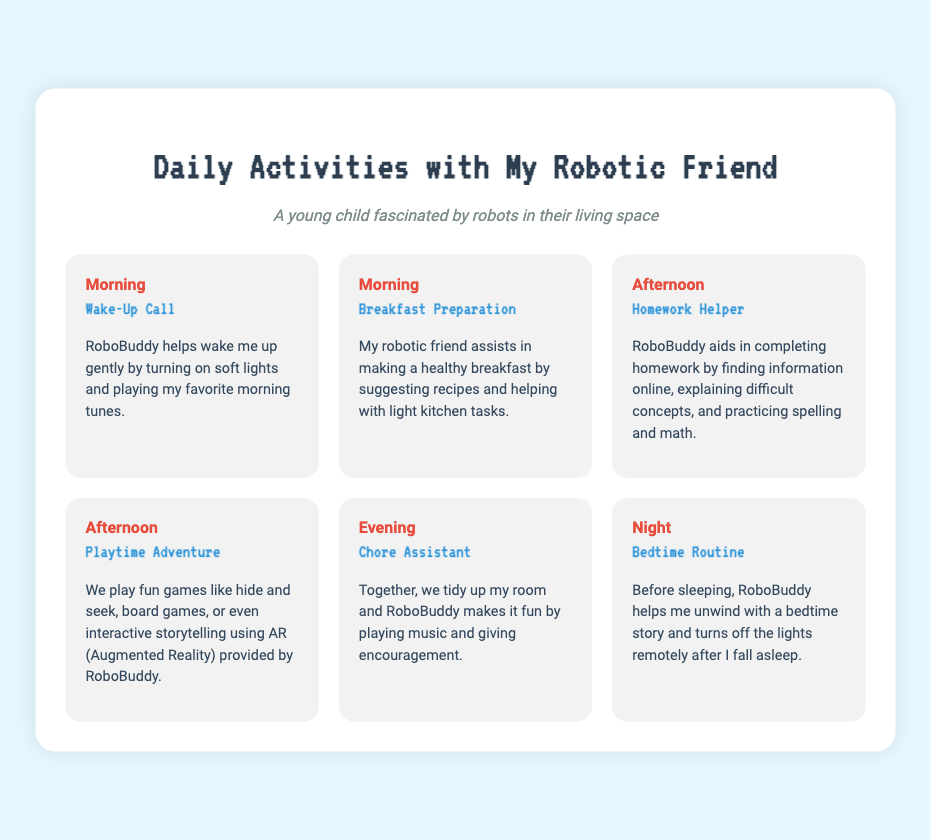What is the title of the document? The title of the document is usually found at the top and is "Daily Activities with My Robotic Friend."
Answer: Daily Activities with My Robotic Friend What activity happens in the morning? The morning activities listed include "Wake-Up Call" and "Breakfast Preparation."
Answer: Wake-Up Call What does RoboBuddy help with during homework? The children's helper, RoboBuddy, aids in completing homework by finding information and explaining difficult concepts.
Answer: Completing homework What time of day is playtime adventure? The activity "Playtime Adventure" is specifically mentioned to occur in the afternoon.
Answer: Afternoon What is RoboBuddy's role in the bedtime routine? RoboBuddy's role in the bedtime routine includes helping to unwind with a story and turning off the lights.
Answer: Help unwind Which activity includes tidying up the room? The activity that involves tidying up the room is called "Chore Assistant."
Answer: Chore Assistant How does RoboBuddy assist with breakfast? RoboBuddy assists by suggesting recipes and helping with light kitchen tasks during breakfast preparation.
Answer: Suggesting recipes What type of games do they play together? The types of games played together during "Playtime Adventure" include hide and seek, board games, and interactive storytelling.
Answer: Hide and seek What is the purpose of RoboBuddy in the morning? The purpose of RoboBuddy in the morning is to help wake the child up gently.
Answer: Help wake up 